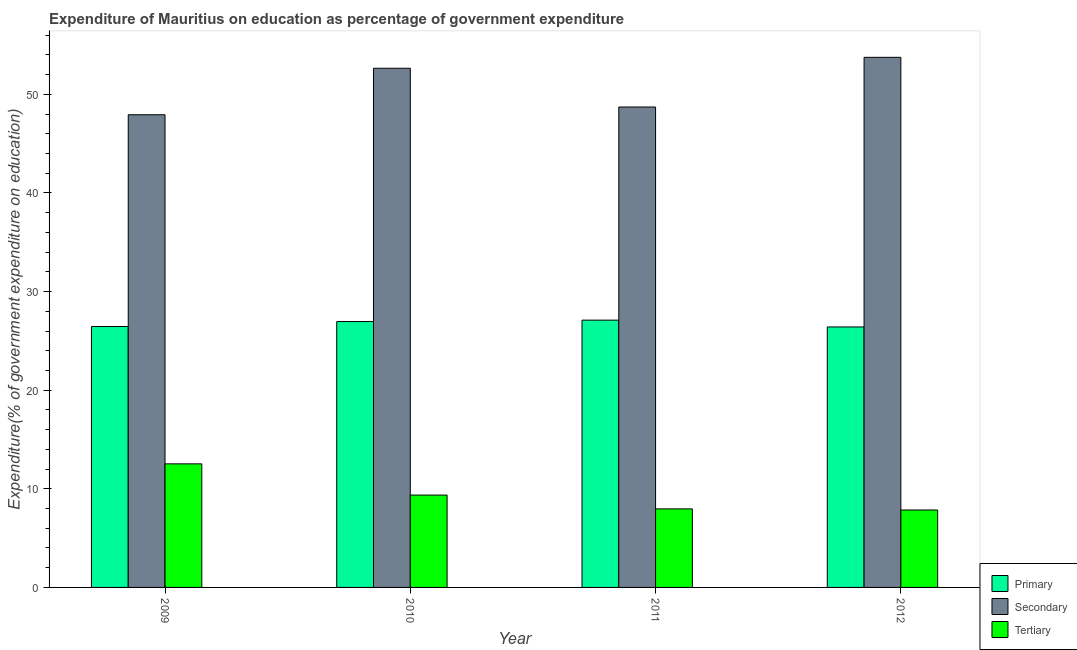How many different coloured bars are there?
Offer a terse response. 3. How many groups of bars are there?
Keep it short and to the point. 4. Are the number of bars per tick equal to the number of legend labels?
Offer a terse response. Yes. How many bars are there on the 3rd tick from the left?
Provide a short and direct response. 3. What is the label of the 3rd group of bars from the left?
Ensure brevity in your answer.  2011. In how many cases, is the number of bars for a given year not equal to the number of legend labels?
Your response must be concise. 0. What is the expenditure on secondary education in 2009?
Give a very brief answer. 47.93. Across all years, what is the maximum expenditure on primary education?
Provide a succinct answer. 27.1. Across all years, what is the minimum expenditure on tertiary education?
Your response must be concise. 7.85. In which year was the expenditure on tertiary education maximum?
Provide a short and direct response. 2009. In which year was the expenditure on primary education minimum?
Your answer should be compact. 2012. What is the total expenditure on primary education in the graph?
Provide a short and direct response. 106.94. What is the difference between the expenditure on tertiary education in 2009 and that in 2012?
Make the answer very short. 4.68. What is the difference between the expenditure on primary education in 2011 and the expenditure on tertiary education in 2012?
Offer a very short reply. 0.69. What is the average expenditure on secondary education per year?
Make the answer very short. 50.76. In the year 2009, what is the difference between the expenditure on primary education and expenditure on tertiary education?
Give a very brief answer. 0. In how many years, is the expenditure on tertiary education greater than 32 %?
Provide a succinct answer. 0. What is the ratio of the expenditure on primary education in 2009 to that in 2011?
Offer a terse response. 0.98. Is the expenditure on primary education in 2009 less than that in 2010?
Offer a terse response. Yes. What is the difference between the highest and the second highest expenditure on tertiary education?
Provide a succinct answer. 3.17. What is the difference between the highest and the lowest expenditure on secondary education?
Provide a succinct answer. 5.82. In how many years, is the expenditure on secondary education greater than the average expenditure on secondary education taken over all years?
Provide a short and direct response. 2. What does the 3rd bar from the left in 2011 represents?
Provide a short and direct response. Tertiary. What does the 3rd bar from the right in 2012 represents?
Offer a terse response. Primary. How many bars are there?
Offer a terse response. 12. How many years are there in the graph?
Keep it short and to the point. 4. Are the values on the major ticks of Y-axis written in scientific E-notation?
Ensure brevity in your answer.  No. Does the graph contain any zero values?
Offer a terse response. No. Does the graph contain grids?
Offer a terse response. No. How many legend labels are there?
Keep it short and to the point. 3. How are the legend labels stacked?
Give a very brief answer. Vertical. What is the title of the graph?
Ensure brevity in your answer.  Expenditure of Mauritius on education as percentage of government expenditure. What is the label or title of the X-axis?
Your answer should be compact. Year. What is the label or title of the Y-axis?
Provide a succinct answer. Expenditure(% of government expenditure on education). What is the Expenditure(% of government expenditure on education) in Primary in 2009?
Keep it short and to the point. 26.46. What is the Expenditure(% of government expenditure on education) in Secondary in 2009?
Ensure brevity in your answer.  47.93. What is the Expenditure(% of government expenditure on education) of Tertiary in 2009?
Your answer should be compact. 12.53. What is the Expenditure(% of government expenditure on education) of Primary in 2010?
Make the answer very short. 26.96. What is the Expenditure(% of government expenditure on education) in Secondary in 2010?
Make the answer very short. 52.65. What is the Expenditure(% of government expenditure on education) of Tertiary in 2010?
Provide a succinct answer. 9.36. What is the Expenditure(% of government expenditure on education) of Primary in 2011?
Keep it short and to the point. 27.1. What is the Expenditure(% of government expenditure on education) in Secondary in 2011?
Provide a succinct answer. 48.72. What is the Expenditure(% of government expenditure on education) in Tertiary in 2011?
Offer a terse response. 7.96. What is the Expenditure(% of government expenditure on education) in Primary in 2012?
Ensure brevity in your answer.  26.41. What is the Expenditure(% of government expenditure on education) of Secondary in 2012?
Your response must be concise. 53.75. What is the Expenditure(% of government expenditure on education) in Tertiary in 2012?
Offer a very short reply. 7.85. Across all years, what is the maximum Expenditure(% of government expenditure on education) in Primary?
Offer a terse response. 27.1. Across all years, what is the maximum Expenditure(% of government expenditure on education) of Secondary?
Your response must be concise. 53.75. Across all years, what is the maximum Expenditure(% of government expenditure on education) in Tertiary?
Your answer should be very brief. 12.53. Across all years, what is the minimum Expenditure(% of government expenditure on education) of Primary?
Give a very brief answer. 26.41. Across all years, what is the minimum Expenditure(% of government expenditure on education) of Secondary?
Offer a very short reply. 47.93. Across all years, what is the minimum Expenditure(% of government expenditure on education) in Tertiary?
Offer a very short reply. 7.85. What is the total Expenditure(% of government expenditure on education) of Primary in the graph?
Your answer should be very brief. 106.94. What is the total Expenditure(% of government expenditure on education) of Secondary in the graph?
Give a very brief answer. 203.05. What is the total Expenditure(% of government expenditure on education) of Tertiary in the graph?
Provide a succinct answer. 37.71. What is the difference between the Expenditure(% of government expenditure on education) of Primary in 2009 and that in 2010?
Offer a very short reply. -0.51. What is the difference between the Expenditure(% of government expenditure on education) in Secondary in 2009 and that in 2010?
Provide a succinct answer. -4.72. What is the difference between the Expenditure(% of government expenditure on education) of Tertiary in 2009 and that in 2010?
Offer a terse response. 3.17. What is the difference between the Expenditure(% of government expenditure on education) of Primary in 2009 and that in 2011?
Offer a terse response. -0.65. What is the difference between the Expenditure(% of government expenditure on education) in Secondary in 2009 and that in 2011?
Keep it short and to the point. -0.79. What is the difference between the Expenditure(% of government expenditure on education) of Tertiary in 2009 and that in 2011?
Ensure brevity in your answer.  4.57. What is the difference between the Expenditure(% of government expenditure on education) of Primary in 2009 and that in 2012?
Ensure brevity in your answer.  0.04. What is the difference between the Expenditure(% of government expenditure on education) of Secondary in 2009 and that in 2012?
Your answer should be compact. -5.82. What is the difference between the Expenditure(% of government expenditure on education) in Tertiary in 2009 and that in 2012?
Offer a very short reply. 4.68. What is the difference between the Expenditure(% of government expenditure on education) in Primary in 2010 and that in 2011?
Give a very brief answer. -0.14. What is the difference between the Expenditure(% of government expenditure on education) in Secondary in 2010 and that in 2011?
Provide a succinct answer. 3.93. What is the difference between the Expenditure(% of government expenditure on education) of Tertiary in 2010 and that in 2011?
Offer a very short reply. 1.4. What is the difference between the Expenditure(% of government expenditure on education) in Primary in 2010 and that in 2012?
Keep it short and to the point. 0.55. What is the difference between the Expenditure(% of government expenditure on education) in Secondary in 2010 and that in 2012?
Provide a succinct answer. -1.11. What is the difference between the Expenditure(% of government expenditure on education) in Tertiary in 2010 and that in 2012?
Ensure brevity in your answer.  1.51. What is the difference between the Expenditure(% of government expenditure on education) of Primary in 2011 and that in 2012?
Make the answer very short. 0.69. What is the difference between the Expenditure(% of government expenditure on education) of Secondary in 2011 and that in 2012?
Your answer should be compact. -5.04. What is the difference between the Expenditure(% of government expenditure on education) of Tertiary in 2011 and that in 2012?
Give a very brief answer. 0.11. What is the difference between the Expenditure(% of government expenditure on education) in Primary in 2009 and the Expenditure(% of government expenditure on education) in Secondary in 2010?
Keep it short and to the point. -26.19. What is the difference between the Expenditure(% of government expenditure on education) in Primary in 2009 and the Expenditure(% of government expenditure on education) in Tertiary in 2010?
Your response must be concise. 17.09. What is the difference between the Expenditure(% of government expenditure on education) in Secondary in 2009 and the Expenditure(% of government expenditure on education) in Tertiary in 2010?
Provide a short and direct response. 38.57. What is the difference between the Expenditure(% of government expenditure on education) in Primary in 2009 and the Expenditure(% of government expenditure on education) in Secondary in 2011?
Your answer should be compact. -22.26. What is the difference between the Expenditure(% of government expenditure on education) of Primary in 2009 and the Expenditure(% of government expenditure on education) of Tertiary in 2011?
Offer a terse response. 18.49. What is the difference between the Expenditure(% of government expenditure on education) of Secondary in 2009 and the Expenditure(% of government expenditure on education) of Tertiary in 2011?
Ensure brevity in your answer.  39.97. What is the difference between the Expenditure(% of government expenditure on education) of Primary in 2009 and the Expenditure(% of government expenditure on education) of Secondary in 2012?
Provide a succinct answer. -27.3. What is the difference between the Expenditure(% of government expenditure on education) of Primary in 2009 and the Expenditure(% of government expenditure on education) of Tertiary in 2012?
Offer a terse response. 18.61. What is the difference between the Expenditure(% of government expenditure on education) of Secondary in 2009 and the Expenditure(% of government expenditure on education) of Tertiary in 2012?
Your answer should be compact. 40.08. What is the difference between the Expenditure(% of government expenditure on education) of Primary in 2010 and the Expenditure(% of government expenditure on education) of Secondary in 2011?
Provide a short and direct response. -21.75. What is the difference between the Expenditure(% of government expenditure on education) in Primary in 2010 and the Expenditure(% of government expenditure on education) in Tertiary in 2011?
Provide a short and direct response. 19. What is the difference between the Expenditure(% of government expenditure on education) of Secondary in 2010 and the Expenditure(% of government expenditure on education) of Tertiary in 2011?
Keep it short and to the point. 44.68. What is the difference between the Expenditure(% of government expenditure on education) of Primary in 2010 and the Expenditure(% of government expenditure on education) of Secondary in 2012?
Keep it short and to the point. -26.79. What is the difference between the Expenditure(% of government expenditure on education) in Primary in 2010 and the Expenditure(% of government expenditure on education) in Tertiary in 2012?
Your answer should be compact. 19.11. What is the difference between the Expenditure(% of government expenditure on education) of Secondary in 2010 and the Expenditure(% of government expenditure on education) of Tertiary in 2012?
Provide a succinct answer. 44.8. What is the difference between the Expenditure(% of government expenditure on education) of Primary in 2011 and the Expenditure(% of government expenditure on education) of Secondary in 2012?
Provide a short and direct response. -26.65. What is the difference between the Expenditure(% of government expenditure on education) in Primary in 2011 and the Expenditure(% of government expenditure on education) in Tertiary in 2012?
Your response must be concise. 19.25. What is the difference between the Expenditure(% of government expenditure on education) in Secondary in 2011 and the Expenditure(% of government expenditure on education) in Tertiary in 2012?
Offer a very short reply. 40.87. What is the average Expenditure(% of government expenditure on education) in Primary per year?
Your answer should be compact. 26.73. What is the average Expenditure(% of government expenditure on education) in Secondary per year?
Keep it short and to the point. 50.76. What is the average Expenditure(% of government expenditure on education) in Tertiary per year?
Keep it short and to the point. 9.43. In the year 2009, what is the difference between the Expenditure(% of government expenditure on education) in Primary and Expenditure(% of government expenditure on education) in Secondary?
Ensure brevity in your answer.  -21.47. In the year 2009, what is the difference between the Expenditure(% of government expenditure on education) in Primary and Expenditure(% of government expenditure on education) in Tertiary?
Make the answer very short. 13.93. In the year 2009, what is the difference between the Expenditure(% of government expenditure on education) of Secondary and Expenditure(% of government expenditure on education) of Tertiary?
Offer a very short reply. 35.4. In the year 2010, what is the difference between the Expenditure(% of government expenditure on education) of Primary and Expenditure(% of government expenditure on education) of Secondary?
Keep it short and to the point. -25.68. In the year 2010, what is the difference between the Expenditure(% of government expenditure on education) of Primary and Expenditure(% of government expenditure on education) of Tertiary?
Make the answer very short. 17.6. In the year 2010, what is the difference between the Expenditure(% of government expenditure on education) in Secondary and Expenditure(% of government expenditure on education) in Tertiary?
Provide a short and direct response. 43.28. In the year 2011, what is the difference between the Expenditure(% of government expenditure on education) in Primary and Expenditure(% of government expenditure on education) in Secondary?
Offer a terse response. -21.61. In the year 2011, what is the difference between the Expenditure(% of government expenditure on education) in Primary and Expenditure(% of government expenditure on education) in Tertiary?
Keep it short and to the point. 19.14. In the year 2011, what is the difference between the Expenditure(% of government expenditure on education) in Secondary and Expenditure(% of government expenditure on education) in Tertiary?
Give a very brief answer. 40.75. In the year 2012, what is the difference between the Expenditure(% of government expenditure on education) of Primary and Expenditure(% of government expenditure on education) of Secondary?
Ensure brevity in your answer.  -27.34. In the year 2012, what is the difference between the Expenditure(% of government expenditure on education) in Primary and Expenditure(% of government expenditure on education) in Tertiary?
Your answer should be very brief. 18.56. In the year 2012, what is the difference between the Expenditure(% of government expenditure on education) of Secondary and Expenditure(% of government expenditure on education) of Tertiary?
Offer a terse response. 45.9. What is the ratio of the Expenditure(% of government expenditure on education) of Primary in 2009 to that in 2010?
Provide a short and direct response. 0.98. What is the ratio of the Expenditure(% of government expenditure on education) of Secondary in 2009 to that in 2010?
Make the answer very short. 0.91. What is the ratio of the Expenditure(% of government expenditure on education) in Tertiary in 2009 to that in 2010?
Provide a succinct answer. 1.34. What is the ratio of the Expenditure(% of government expenditure on education) of Primary in 2009 to that in 2011?
Offer a very short reply. 0.98. What is the ratio of the Expenditure(% of government expenditure on education) of Secondary in 2009 to that in 2011?
Keep it short and to the point. 0.98. What is the ratio of the Expenditure(% of government expenditure on education) of Tertiary in 2009 to that in 2011?
Provide a succinct answer. 1.57. What is the ratio of the Expenditure(% of government expenditure on education) in Primary in 2009 to that in 2012?
Your answer should be compact. 1. What is the ratio of the Expenditure(% of government expenditure on education) in Secondary in 2009 to that in 2012?
Your answer should be compact. 0.89. What is the ratio of the Expenditure(% of government expenditure on education) of Tertiary in 2009 to that in 2012?
Provide a short and direct response. 1.6. What is the ratio of the Expenditure(% of government expenditure on education) in Primary in 2010 to that in 2011?
Ensure brevity in your answer.  0.99. What is the ratio of the Expenditure(% of government expenditure on education) in Secondary in 2010 to that in 2011?
Keep it short and to the point. 1.08. What is the ratio of the Expenditure(% of government expenditure on education) in Tertiary in 2010 to that in 2011?
Your answer should be compact. 1.18. What is the ratio of the Expenditure(% of government expenditure on education) of Primary in 2010 to that in 2012?
Offer a very short reply. 1.02. What is the ratio of the Expenditure(% of government expenditure on education) of Secondary in 2010 to that in 2012?
Make the answer very short. 0.98. What is the ratio of the Expenditure(% of government expenditure on education) of Tertiary in 2010 to that in 2012?
Your answer should be very brief. 1.19. What is the ratio of the Expenditure(% of government expenditure on education) in Primary in 2011 to that in 2012?
Your answer should be very brief. 1.03. What is the ratio of the Expenditure(% of government expenditure on education) in Secondary in 2011 to that in 2012?
Your answer should be very brief. 0.91. What is the ratio of the Expenditure(% of government expenditure on education) in Tertiary in 2011 to that in 2012?
Your answer should be very brief. 1.01. What is the difference between the highest and the second highest Expenditure(% of government expenditure on education) in Primary?
Give a very brief answer. 0.14. What is the difference between the highest and the second highest Expenditure(% of government expenditure on education) of Secondary?
Provide a short and direct response. 1.11. What is the difference between the highest and the second highest Expenditure(% of government expenditure on education) of Tertiary?
Offer a very short reply. 3.17. What is the difference between the highest and the lowest Expenditure(% of government expenditure on education) in Primary?
Your response must be concise. 0.69. What is the difference between the highest and the lowest Expenditure(% of government expenditure on education) of Secondary?
Your response must be concise. 5.82. What is the difference between the highest and the lowest Expenditure(% of government expenditure on education) of Tertiary?
Offer a terse response. 4.68. 